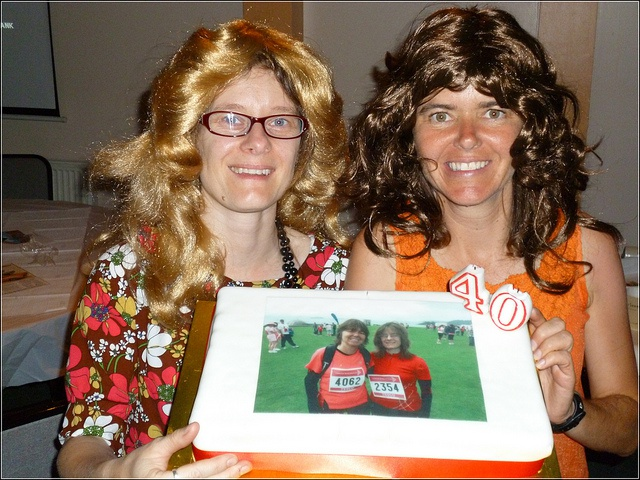Describe the objects in this image and their specific colors. I can see people in black, maroon, and tan tones, people in black, tan, maroon, and gray tones, and cake in black, white, green, gray, and salmon tones in this image. 